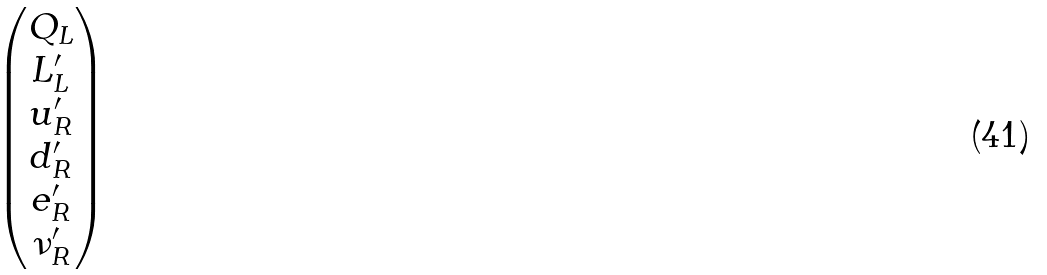Convert formula to latex. <formula><loc_0><loc_0><loc_500><loc_500>\begin{pmatrix} Q _ { L } \\ L ^ { \prime } _ { L } \\ u ^ { \prime } _ { R } \\ d ^ { \prime } _ { R } \\ e ^ { \prime } _ { R } \\ \nu ^ { \prime } _ { R } \\ \end{pmatrix}</formula> 